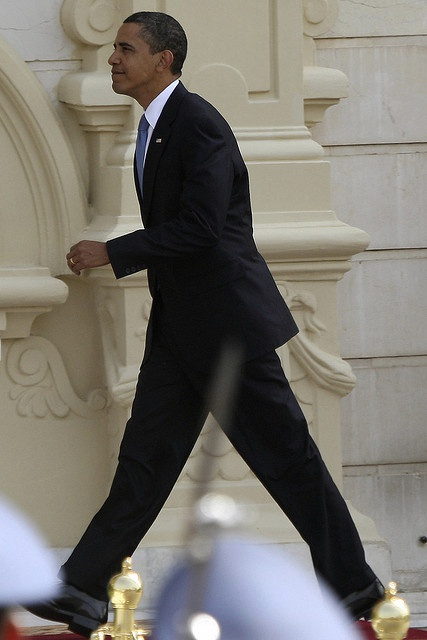Describe the objects in this image and their specific colors. I can see people in darkgray, black, maroon, and gray tones and tie in darkgray, gray, black, navy, and darkblue tones in this image. 